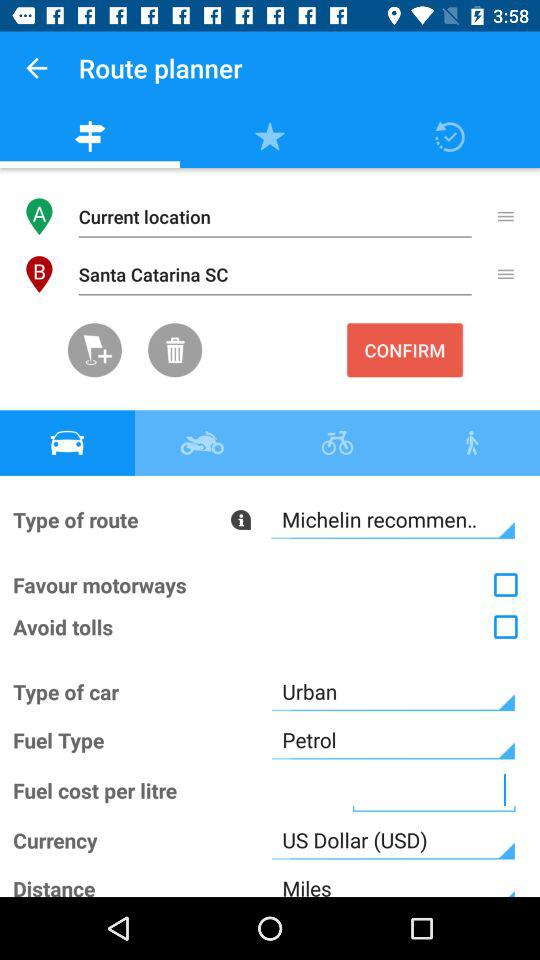What is the type of route? The type of route is "Michelin recommen..". 